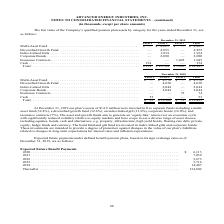From Advanced Energy's financial document, What were the funds that the company invested in in 2019? The document contains multiple relevant values: multi-asset fund, diversified growth fund, index-linked gilt, corporate bonds, insurance contracts. From the document: "Multi-Asset Fund . $ — $ 4,825 $ — $ 4,825 Diversified Growth Fund . — 4,855 — 4,855 Index-Linked Gilts . — 1,934 — 1,934 Corporate Bonds . — 2,090 — ..." Also, How many assets was in the Level 2 Multi-Asset fund for 2019? According to the financial document, $4,825 (in thousands). The relevant text states: "Multi-Asset Fund . $ — $ 4,825 $ — $ 4,825..." Also, How many assets was in the Level 2 Corporate Bonds for 2018? According to the financial document, 2,044 (in thousands). The relevant text states: "wth Fund . — 4,650 — 4,650 Index-Linked Gilts . — 2,044 — 2,044 Corporate Bonds . — 2,044 — 2,044 Insurance Contracts . — — 72 72 Cash . 53 — — 53 Total ...." Also, can you calculate: What was the difference in the total assets in the Level 1 Level 2 categories for 2019? Based on the calculation: $13,704-$154, the result is 13550 (in thousands). This is based on the information: ",090 Insurance Contracts . — — 1,045 1,045 Cash . 154 — — 154 Total . $ 154 $ 13,704 $ 1,045 $ 14,903 — 1,045 1,045 Cash . 154 — — 154 Total . $ 154 $ 13,704 $ 1,045 $ 14,903..." The key data points involved are: 13,704, 154. Also, can you calculate: What was the total of the three highest assets in the Level 2 Category for 2019? Based on the calculation: 4,855+$4,825+2,090, the result is 11770 (in thousands). This is based on the information: "Diversified Growth Fund . — 4,855 — 4,855 Index-Linked Gilts . — 1,934 — 1,934 Corporate Bonds . — 2,090 — 2,090 Insurance Contracts inked Gilts . — 1,934 — 1,934 Corporate Bonds . — 2,090 — 2,090 Ins..." The key data points involved are: 2,090, 4,825, 4,855. Also, can you calculate: What percentage of total assets across all categories consisted of assets from the Level One category for 2019? Based on the calculation: $154/$14,903, the result is 1.03 (percentage). This is based on the information: ",090 Insurance Contracts . — — 1,045 1,045 Cash . 154 — — 154 Total . $ 154 $ 13,704 $ 1,045 $ 14,903 sh . 154 — — 154 Total . $ 154 $ 13,704 $ 1,045 $ 14,903..." The key data points involved are: 14,903, 154. 